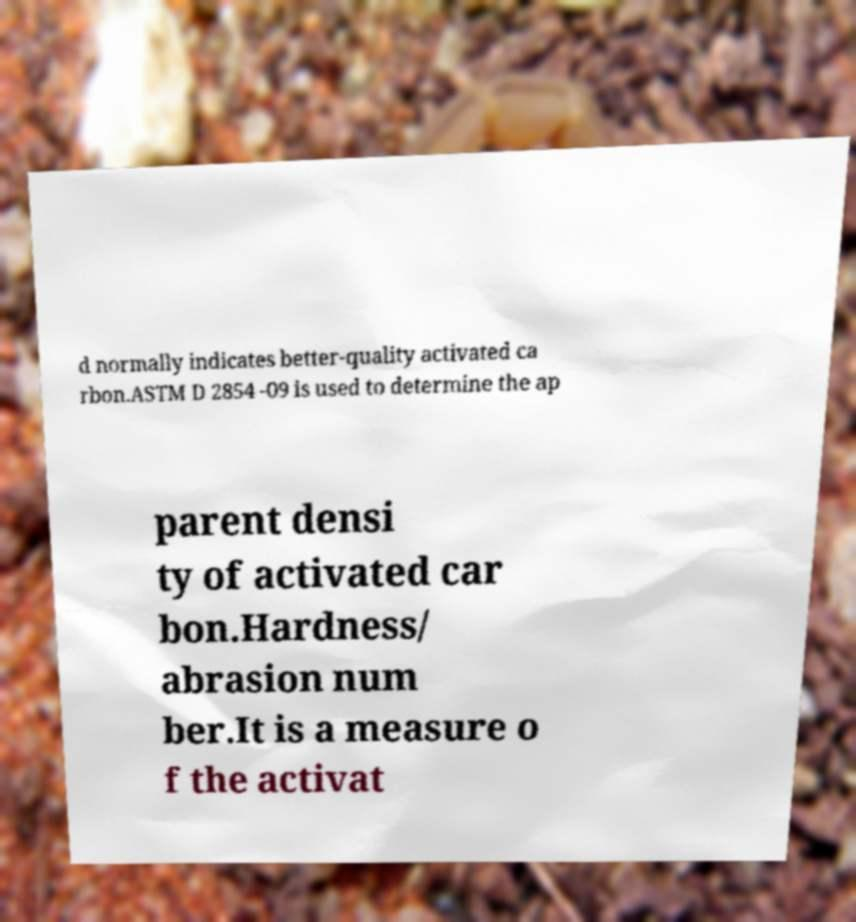Could you assist in decoding the text presented in this image and type it out clearly? d normally indicates better-quality activated ca rbon.ASTM D 2854 -09 is used to determine the ap parent densi ty of activated car bon.Hardness/ abrasion num ber.It is a measure o f the activat 